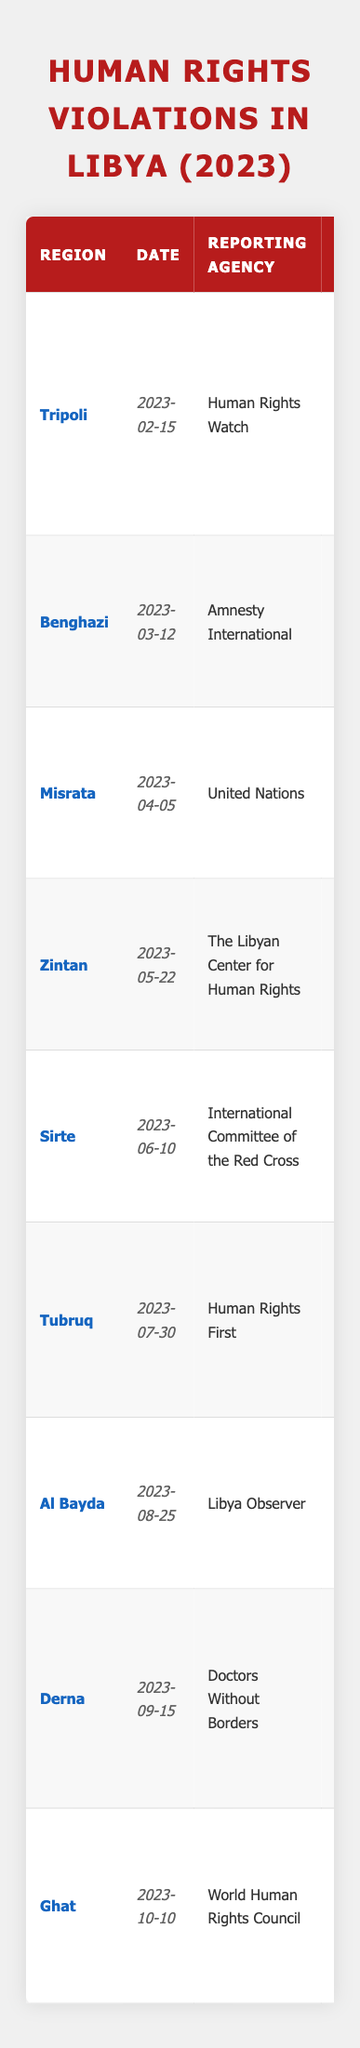What is the total number of reported cases of human rights violations in Libya in 2023? By summing the "Cases" column from each region, we have: 150 (Tripoli) + 20 (Benghazi) + 75 (Misrata) + 300 (Zintan) + 10 (Sirte) + 50 (Tubruq) + 40 (Al Bayda) + 500 (Derna) + 25 (Ghat) = 1,170 cases.
Answer: 1,170 Which region reported the highest number of cases in 2023? Looking through the "Cases" column, Zintan has the highest number at 300 cases, compared to other regions.
Answer: Zintan How many reports were made regarding torture in Libya in 2023? Referring to the table, there is only one report about torture from Misrata that states 75 cases.
Answer: 1 Was there a report of arbitrary detention in Tripoli? The table shows that Tripoli reported 150 cases of arbitrary detention, confirming that there was such a report.
Answer: Yes What is the average number of reported cases across all regions in 2023? There are 9 regions, with a total of 1,170 cases. The average is calculated as 1,170 / 9 = 130.
Answer: 130 How many instances of attacks on healthcare were reported in Sirte? The table specifies that there were 10 documented attacks on healthcare in Sirte.
Answer: 10 Is the number of extrajudicial killings in Benghazi greater than the number of violations against refugees in Tubruq? There are 20 extrajudicial killings in Benghazi and 50 violations against refugees in Tubruq; 20 is less than 50.
Answer: No In which region did the highest individual case count occur related to health crises due to conflict? The report from Derna indicates there were 500 cases related to health crises, which is the highest in the table.
Answer: Derna How many family displacements were reported in Zintan due to clashes? The report indicates that 300 families were forcibly displaced in Zintan due to ongoing clashes.
Answer: 300 Are there reports of child recruitment in Ghat? Yes, the table confirms that there are reports of 25 child recruitments by armed groups in Ghat.
Answer: Yes 